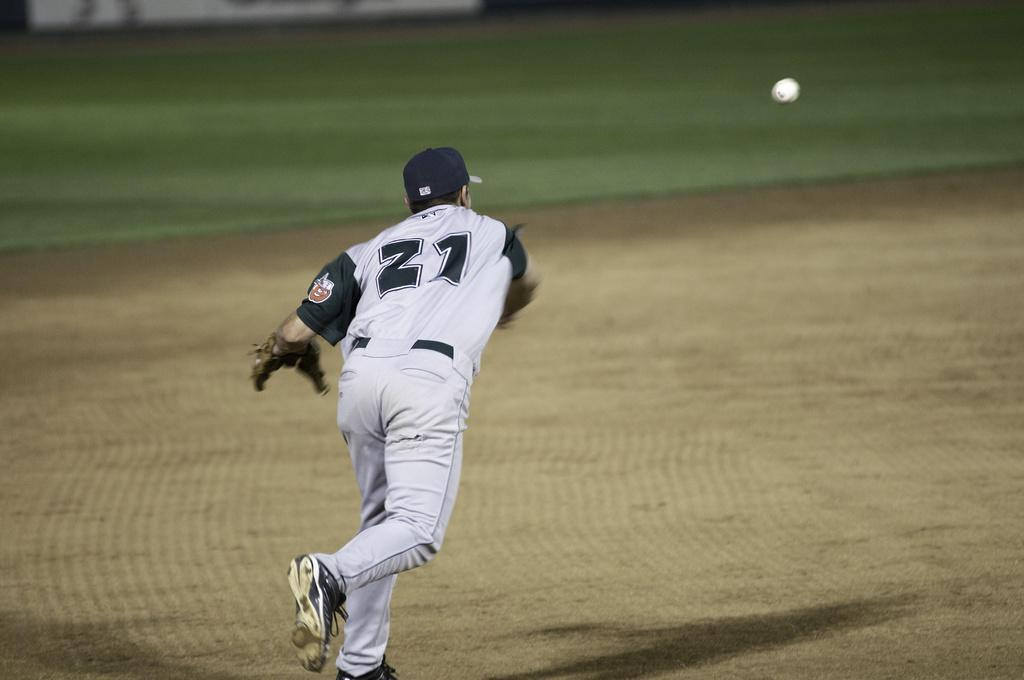<image>
Describe the image concisely. a player that has the number 21 on it 